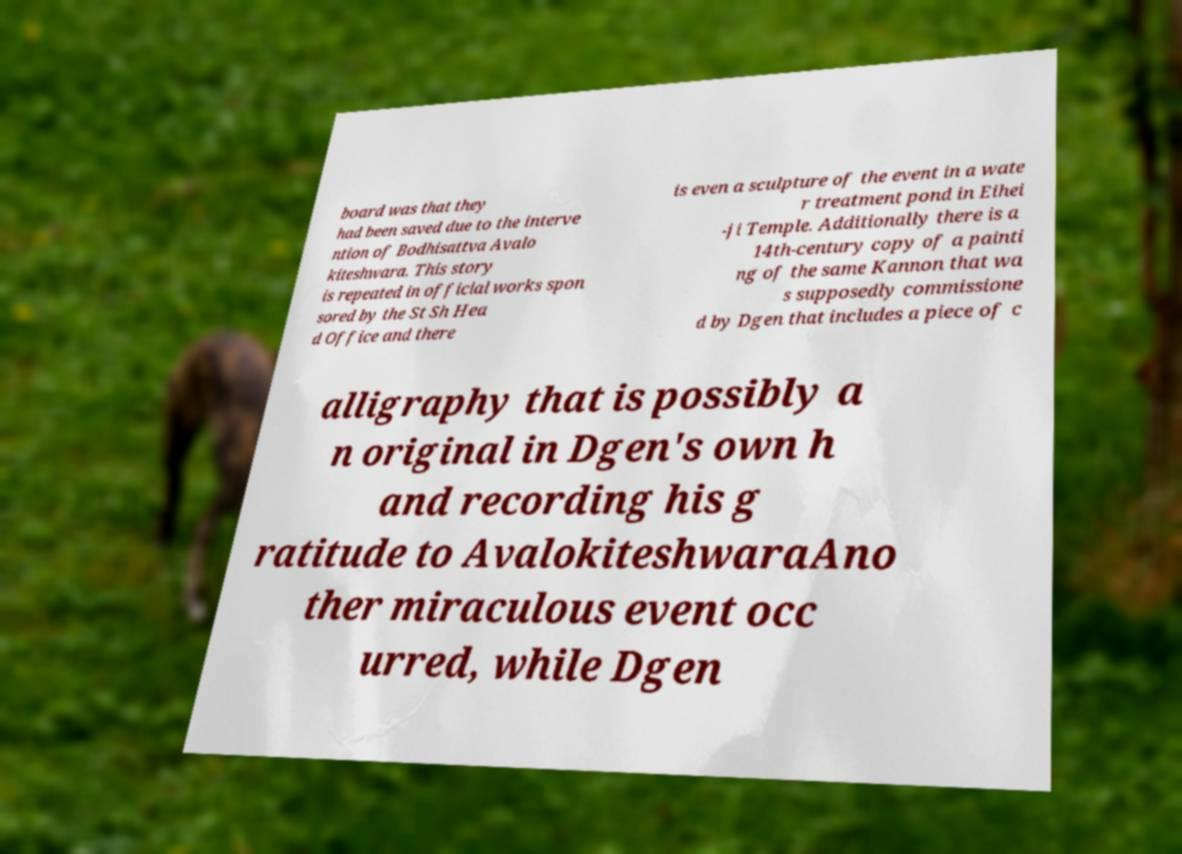I need the written content from this picture converted into text. Can you do that? board was that they had been saved due to the interve ntion of Bodhisattva Avalo kiteshwara. This story is repeated in official works spon sored by the St Sh Hea d Office and there is even a sculpture of the event in a wate r treatment pond in Eihei -ji Temple. Additionally there is a 14th-century copy of a painti ng of the same Kannon that wa s supposedly commissione d by Dgen that includes a piece of c alligraphy that is possibly a n original in Dgen's own h and recording his g ratitude to AvalokiteshwaraAno ther miraculous event occ urred, while Dgen 